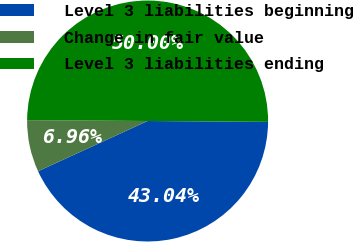Convert chart. <chart><loc_0><loc_0><loc_500><loc_500><pie_chart><fcel>Level 3 liabilities beginning<fcel>Change in fair value<fcel>Level 3 liabilities ending<nl><fcel>43.04%<fcel>6.96%<fcel>50.0%<nl></chart> 